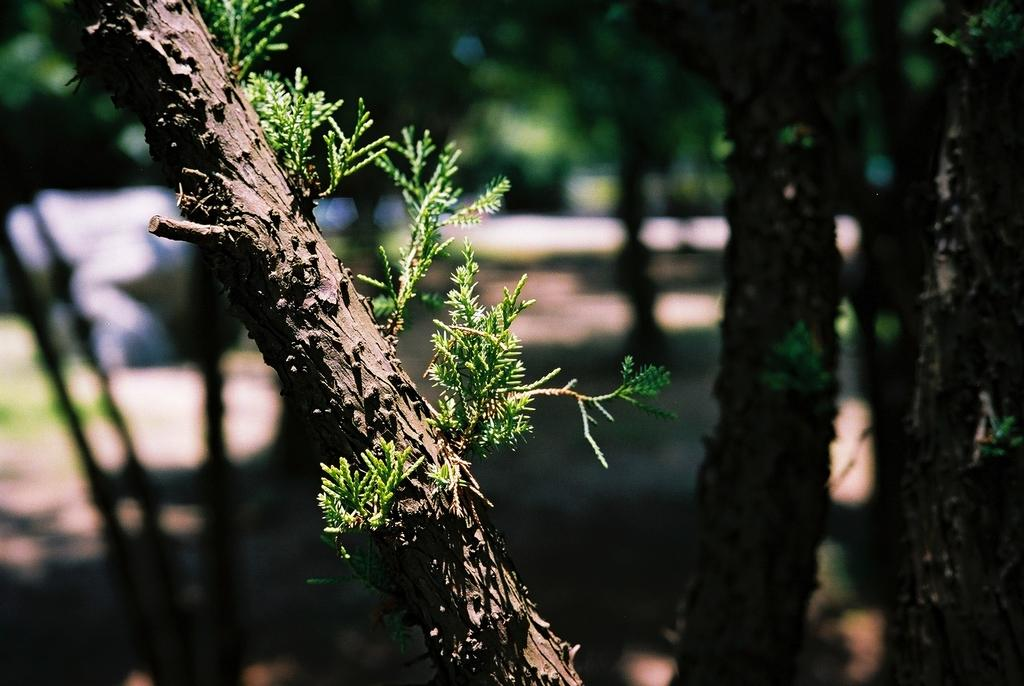What is depicted on the stem in the image? There are leaves on a stem in the image. What can be seen on the right side of the image? There are tree trunks on the right side of the image. How would you describe the background of the image? The background of the image is blurred. What color crayon is being used to draw the leaves in the image? There is no crayon present in the image; it is a photograph of leaves on a stem. Who is the manager of the tree depicted in the image? There is no manager present in the image; it is a photograph of tree trunks and leaves on a stem. 